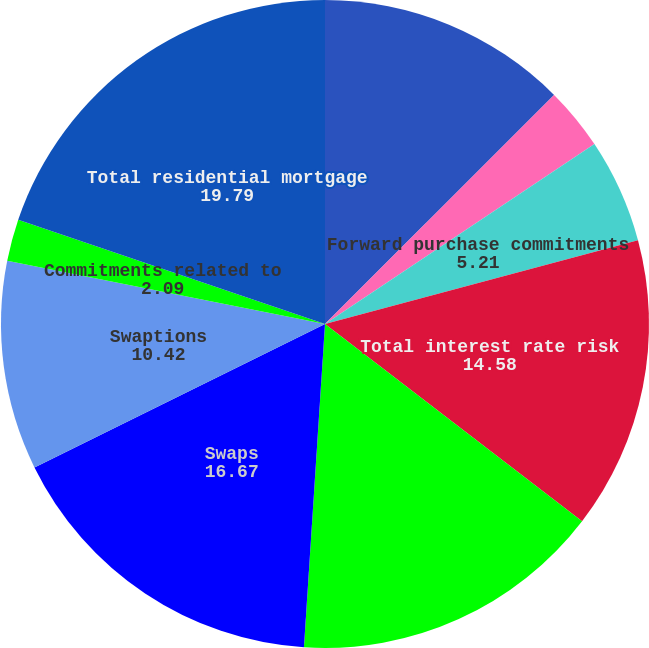Convert chart to OTSL. <chart><loc_0><loc_0><loc_500><loc_500><pie_chart><fcel>Receive fixed swaps<fcel>Pay fixed swaps (c) (d)<fcel>Forward purchase commitments<fcel>Total interest rate risk<fcel>Total derivatives designated<fcel>Swaps<fcel>Swaptions<fcel>Commitments related to<fcel>Total residential mortgage<nl><fcel>12.5%<fcel>3.13%<fcel>5.21%<fcel>14.58%<fcel>15.62%<fcel>16.67%<fcel>10.42%<fcel>2.09%<fcel>19.79%<nl></chart> 